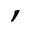<formula> <loc_0><loc_0><loc_500><loc_500>,</formula> 